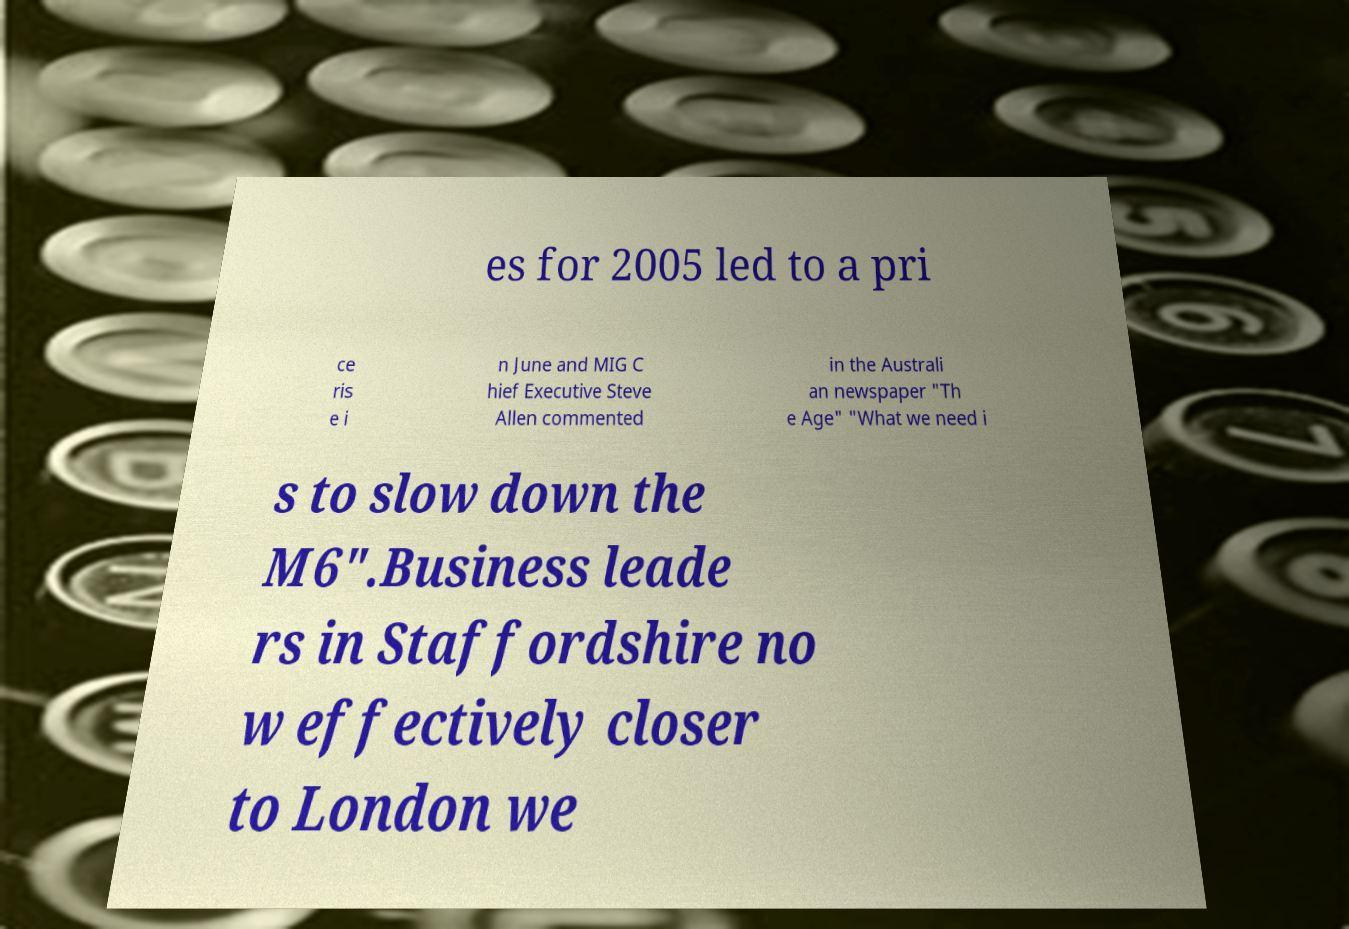Can you read and provide the text displayed in the image?This photo seems to have some interesting text. Can you extract and type it out for me? es for 2005 led to a pri ce ris e i n June and MIG C hief Executive Steve Allen commented in the Australi an newspaper "Th e Age" "What we need i s to slow down the M6".Business leade rs in Staffordshire no w effectively closer to London we 